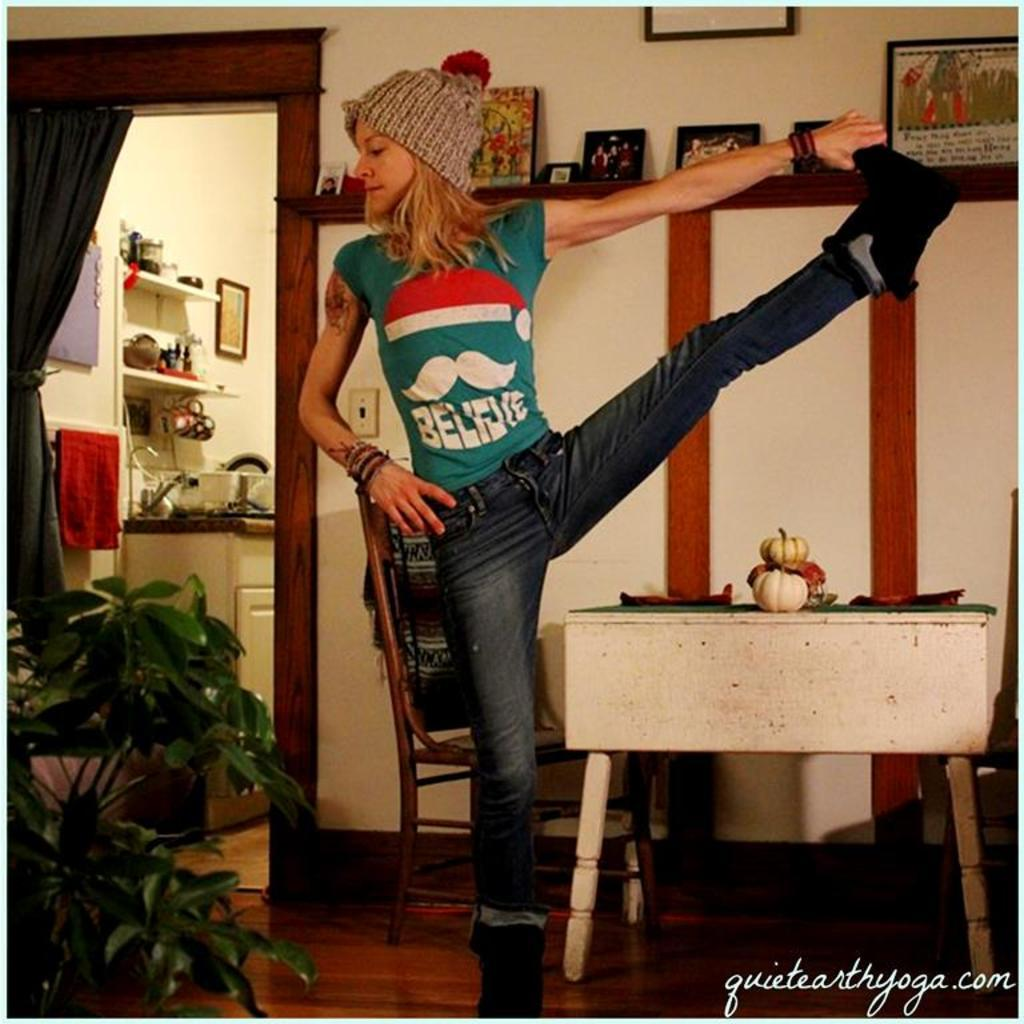Who is the main subject in the image? There is a woman in the image. What is the woman doing in the image? The woman is standing and stretching one of her legs. How is the woman holding her leg? The woman is holding her leg with her hand. What type of bottle is the woman holding in the image? There is no bottle present in the image; the woman is holding her leg with her hand. What religious symbol can be seen in the image? There is no religious symbol present in the image; it only features a woman stretching her leg. 